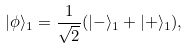<formula> <loc_0><loc_0><loc_500><loc_500>| \phi \rangle _ { 1 } = \frac { 1 } { \sqrt { 2 } } ( | - \rangle _ { 1 } + | + \rangle _ { 1 } ) ,</formula> 